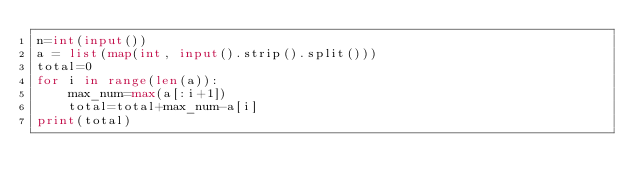Convert code to text. <code><loc_0><loc_0><loc_500><loc_500><_Python_>n=int(input())
a = list(map(int, input().strip().split()))
total=0
for i in range(len(a)):
    max_num=max(a[:i+1])
    total=total+max_num-a[i]
print(total)</code> 